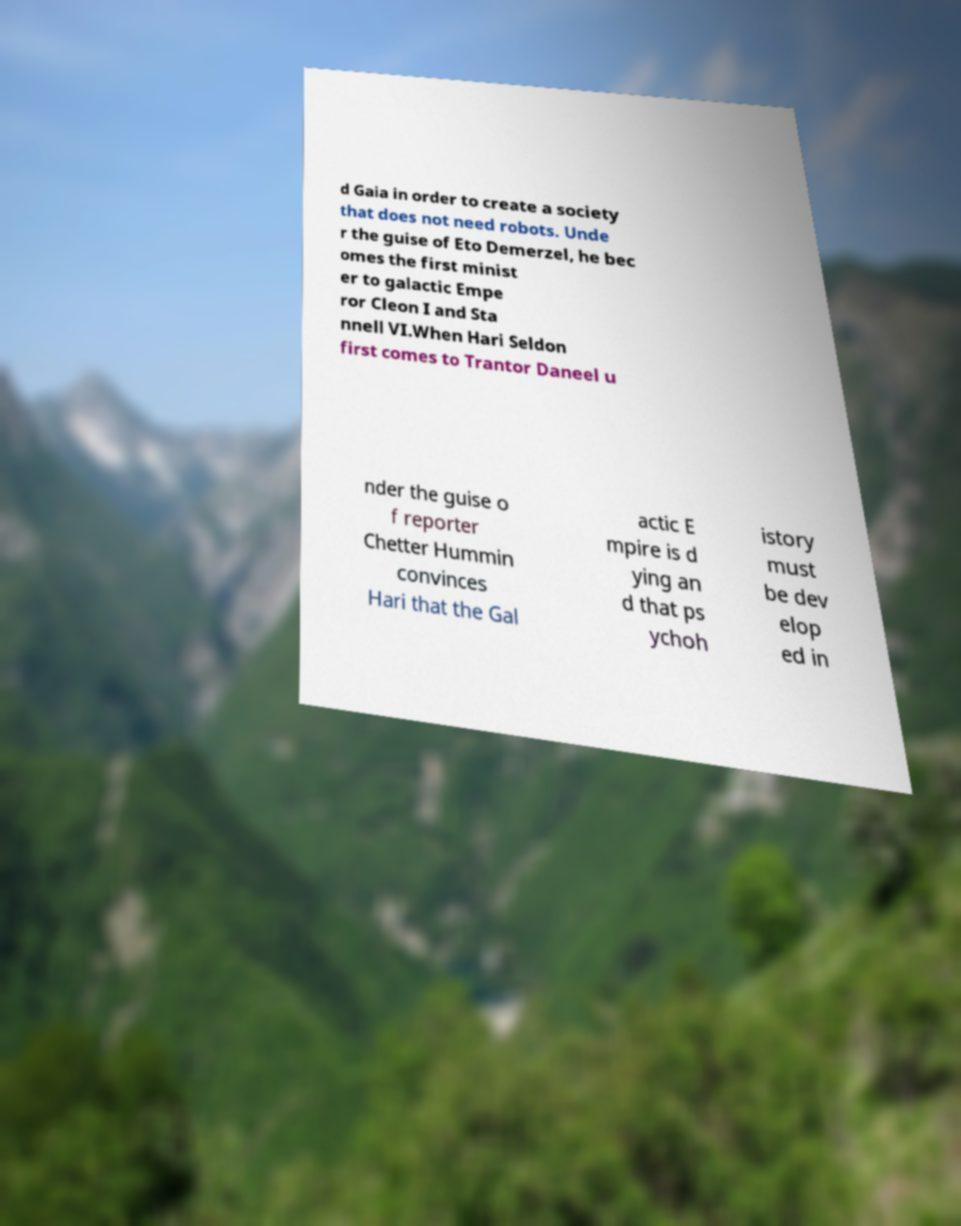Could you extract and type out the text from this image? d Gaia in order to create a society that does not need robots. Unde r the guise of Eto Demerzel, he bec omes the first minist er to galactic Empe ror Cleon I and Sta nnell VI.When Hari Seldon first comes to Trantor Daneel u nder the guise o f reporter Chetter Hummin convinces Hari that the Gal actic E mpire is d ying an d that ps ychoh istory must be dev elop ed in 